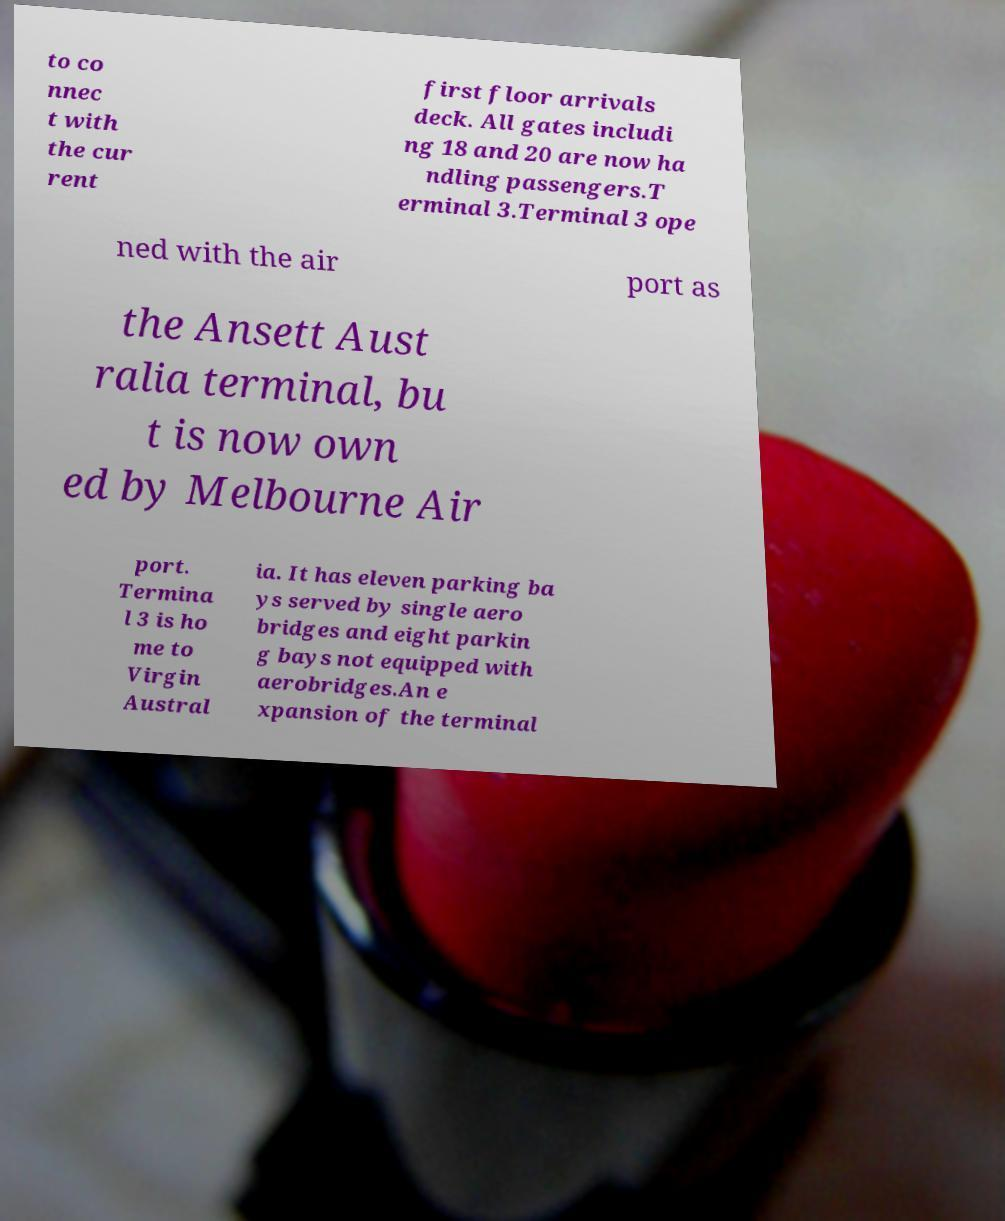What messages or text are displayed in this image? I need them in a readable, typed format. to co nnec t with the cur rent first floor arrivals deck. All gates includi ng 18 and 20 are now ha ndling passengers.T erminal 3.Terminal 3 ope ned with the air port as the Ansett Aust ralia terminal, bu t is now own ed by Melbourne Air port. Termina l 3 is ho me to Virgin Austral ia. It has eleven parking ba ys served by single aero bridges and eight parkin g bays not equipped with aerobridges.An e xpansion of the terminal 